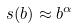<formula> <loc_0><loc_0><loc_500><loc_500>s ( b ) \approx b ^ { \alpha }</formula> 